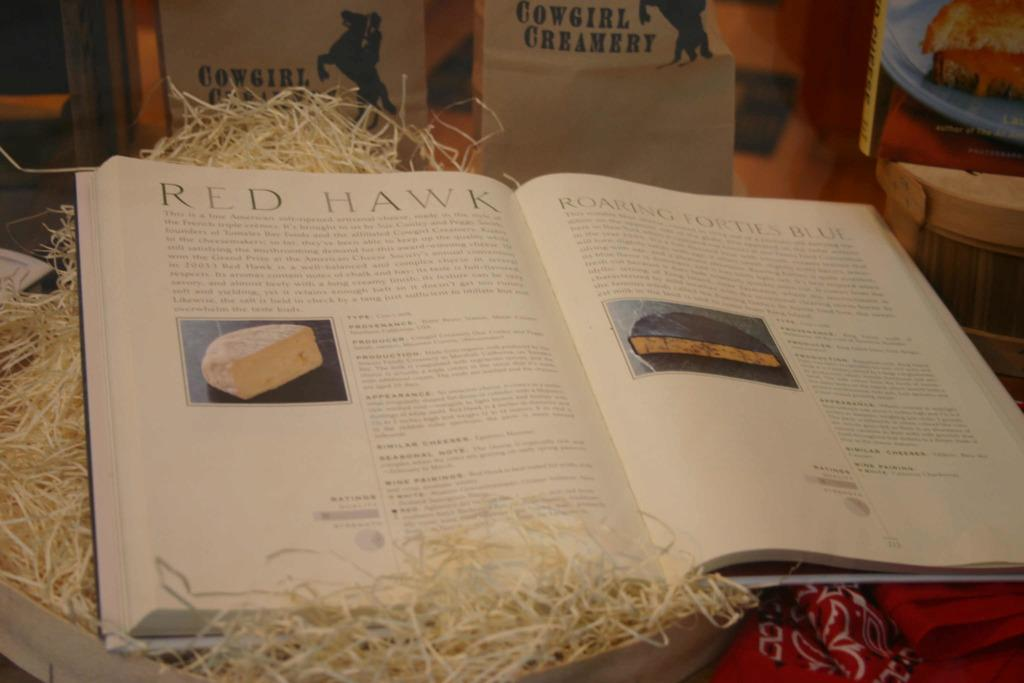<image>
Create a compact narrative representing the image presented. A book is open to the section titled "red hawk". 